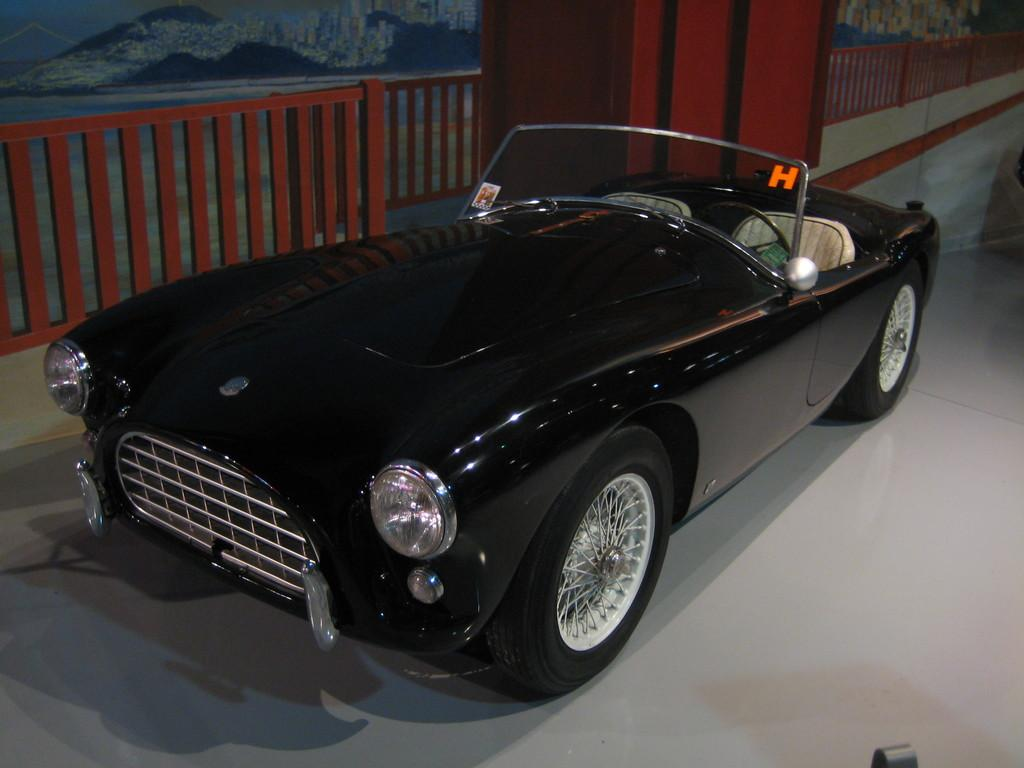What type of toy is visible in the image? There is a black color toy car in the image. What can be seen behind the toy car? There appears to be a poster behind the toy car. How many books are stacked on the toy car in the image? There are no books present in the image; it only features a toy car and a poster. 